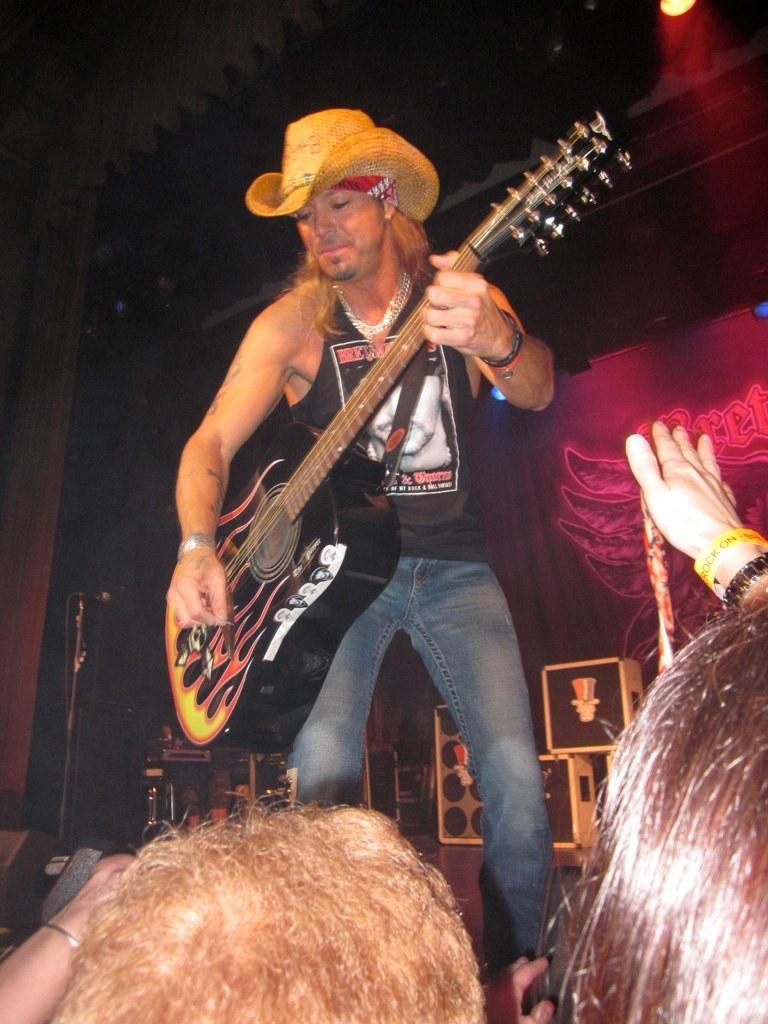Please provide a concise description of this image. In this picture there is a man standing on the stage playing a guitar in his hands. He is wearing a hat. There are some audience in the down enjoying his music. In the background there is a poster. 